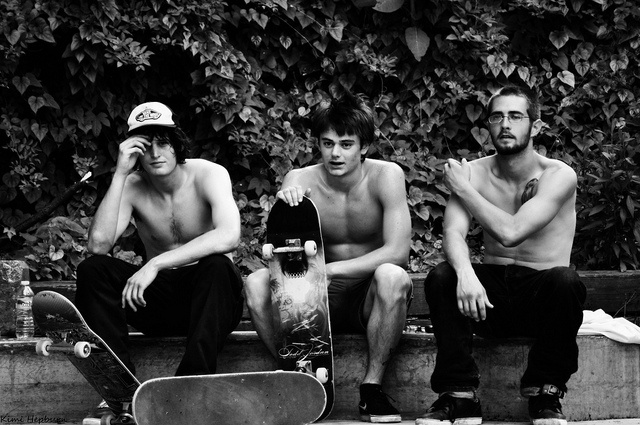Describe the objects in this image and their specific colors. I can see people in black, darkgray, lightgray, and gray tones, people in black, lightgray, darkgray, and gray tones, people in black, darkgray, gray, and lightgray tones, skateboard in black, darkgray, lightgray, and gray tones, and skateboard in black, gray, and silver tones in this image. 